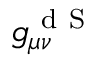Convert formula to latex. <formula><loc_0><loc_0><loc_500><loc_500>g _ { \mu \nu } ^ { d S }</formula> 